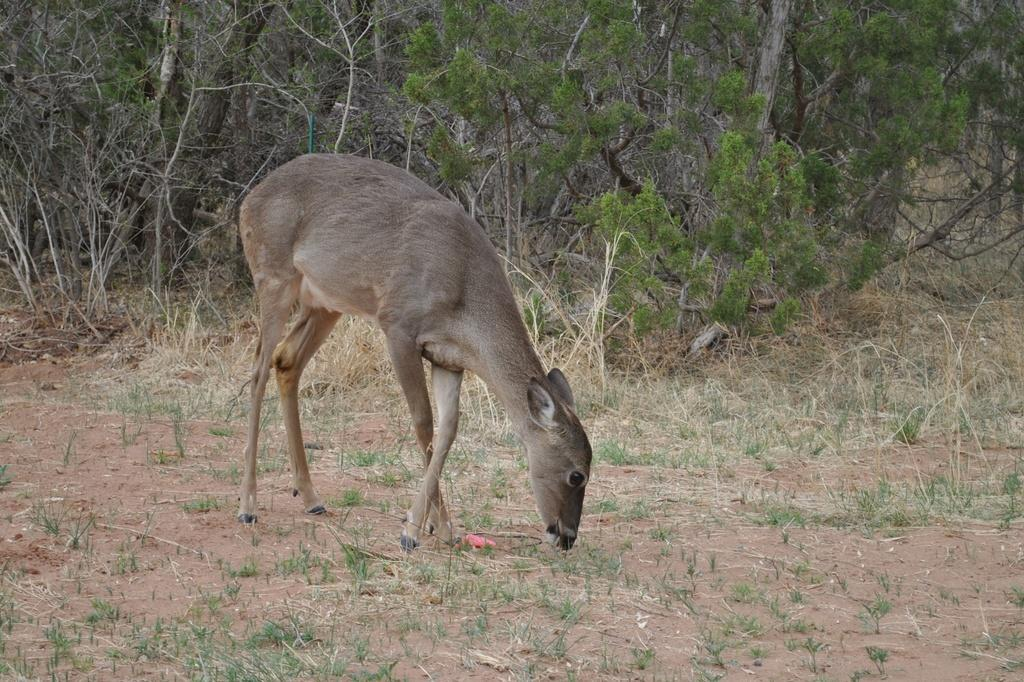What animal can be seen in the image? There is a deer in the image. Where is the deer located? The deer is on the ground. What type of vegetation is visible in the image? There is grass visible in the image. What can be seen in the background of the image? There are plants and trees in the background of the image. How many eggs are the deer is holding in the image? There are no eggs visible in the image. 